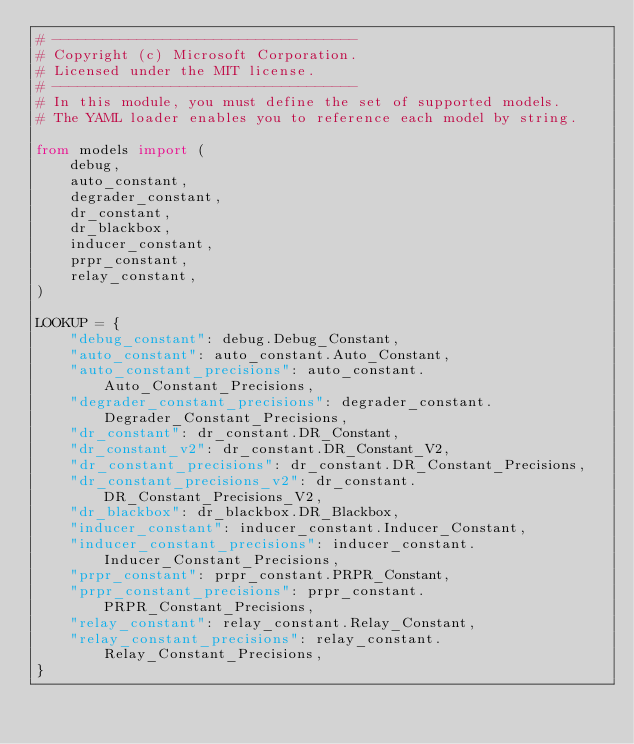Convert code to text. <code><loc_0><loc_0><loc_500><loc_500><_Python_># ------------------------------------
# Copyright (c) Microsoft Corporation.
# Licensed under the MIT license.
# ------------------------------------
# In this module, you must define the set of supported models.
# The YAML loader enables you to reference each model by string.

from models import (
    debug,
    auto_constant,
    degrader_constant,
    dr_constant,
    dr_blackbox,
    inducer_constant,
    prpr_constant,
    relay_constant,
)

LOOKUP = {
    "debug_constant": debug.Debug_Constant,
    "auto_constant": auto_constant.Auto_Constant,
    "auto_constant_precisions": auto_constant.Auto_Constant_Precisions,
    "degrader_constant_precisions": degrader_constant.Degrader_Constant_Precisions,
    "dr_constant": dr_constant.DR_Constant,
    "dr_constant_v2": dr_constant.DR_Constant_V2,
    "dr_constant_precisions": dr_constant.DR_Constant_Precisions,
    "dr_constant_precisions_v2": dr_constant.DR_Constant_Precisions_V2,
    "dr_blackbox": dr_blackbox.DR_Blackbox,
    "inducer_constant": inducer_constant.Inducer_Constant,
    "inducer_constant_precisions": inducer_constant.Inducer_Constant_Precisions,
    "prpr_constant": prpr_constant.PRPR_Constant,
    "prpr_constant_precisions": prpr_constant.PRPR_Constant_Precisions,
    "relay_constant": relay_constant.Relay_Constant,
    "relay_constant_precisions": relay_constant.Relay_Constant_Precisions,
}
</code> 